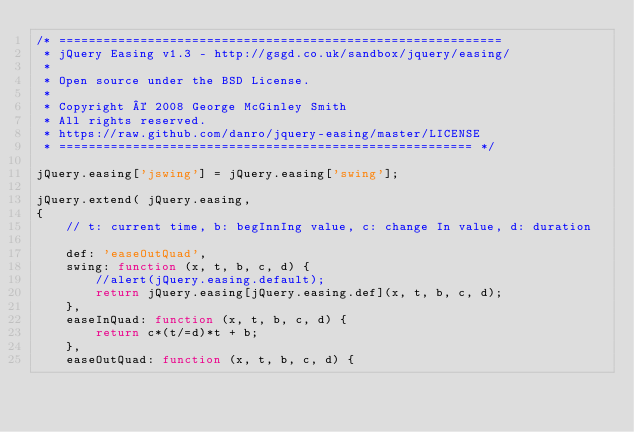<code> <loc_0><loc_0><loc_500><loc_500><_JavaScript_>/* ============================================================
 * jQuery Easing v1.3 - http://gsgd.co.uk/sandbox/jquery/easing/
 *
 * Open source under the BSD License.
 *
 * Copyright © 2008 George McGinley Smith
 * All rights reserved.
 * https://raw.github.com/danro/jquery-easing/master/LICENSE
 * ======================================================== */

jQuery.easing['jswing'] = jQuery.easing['swing'];

jQuery.extend( jQuery.easing,
{
	// t: current time, b: begInnIng value, c: change In value, d: duration
	
	def: 'easeOutQuad',
	swing: function (x, t, b, c, d) {
		//alert(jQuery.easing.default);
		return jQuery.easing[jQuery.easing.def](x, t, b, c, d);
	},
	easeInQuad: function (x, t, b, c, d) {
		return c*(t/=d)*t + b;
	},
	easeOutQuad: function (x, t, b, c, d) {</code> 